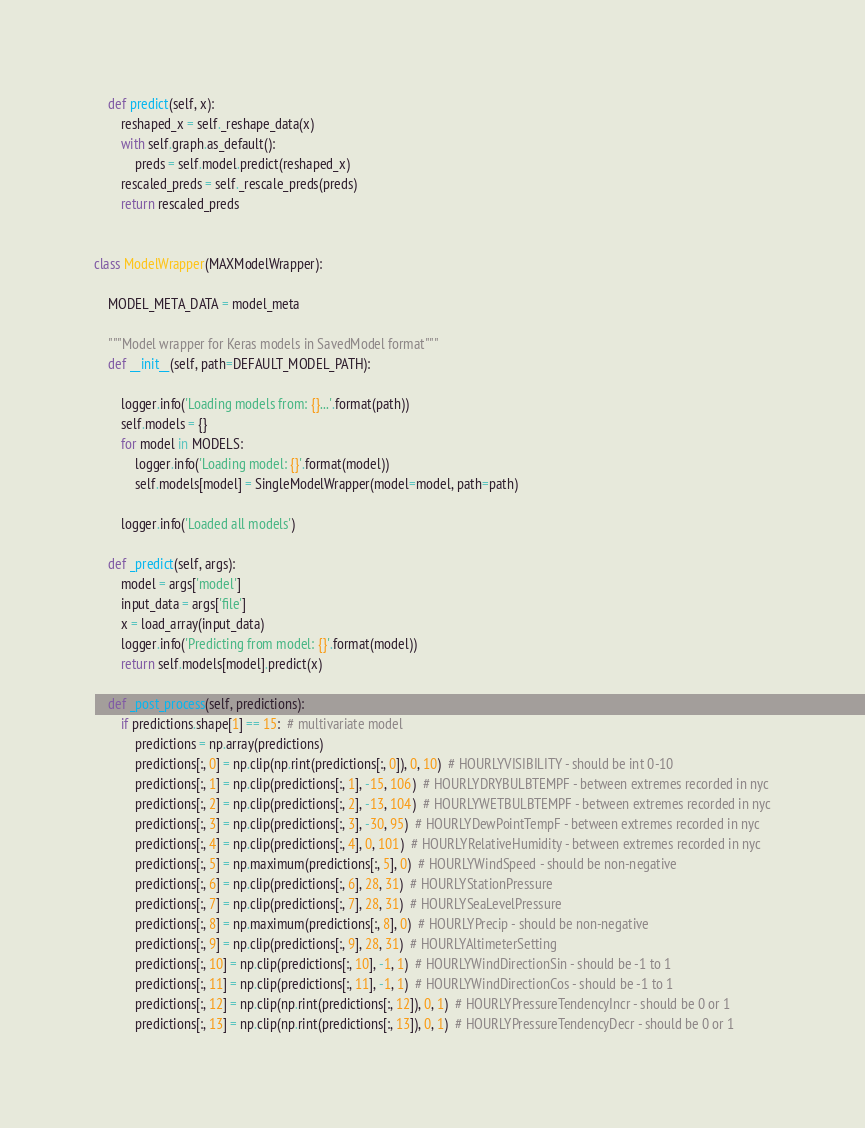Convert code to text. <code><loc_0><loc_0><loc_500><loc_500><_Python_>
    def predict(self, x):
        reshaped_x = self._reshape_data(x)
        with self.graph.as_default():
            preds = self.model.predict(reshaped_x)
        rescaled_preds = self._rescale_preds(preds)
        return rescaled_preds


class ModelWrapper(MAXModelWrapper):

    MODEL_META_DATA = model_meta

    """Model wrapper for Keras models in SavedModel format"""
    def __init__(self, path=DEFAULT_MODEL_PATH):

        logger.info('Loading models from: {}...'.format(path))
        self.models = {}
        for model in MODELS:
            logger.info('Loading model: {}'.format(model))
            self.models[model] = SingleModelWrapper(model=model, path=path)

        logger.info('Loaded all models')

    def _predict(self, args):
        model = args['model']
        input_data = args['file']
        x = load_array(input_data)
        logger.info('Predicting from model: {}'.format(model))
        return self.models[model].predict(x)

    def _post_process(self, predictions):
        if predictions.shape[1] == 15:  # multivariate model
            predictions = np.array(predictions)
            predictions[:, 0] = np.clip(np.rint(predictions[:, 0]), 0, 10)  # HOURLYVISIBILITY - should be int 0-10
            predictions[:, 1] = np.clip(predictions[:, 1], -15, 106)  # HOURLYDRYBULBTEMPF - between extremes recorded in nyc
            predictions[:, 2] = np.clip(predictions[:, 2], -13, 104)  # HOURLYWETBULBTEMPF - between extremes recorded in nyc
            predictions[:, 3] = np.clip(predictions[:, 3], -30, 95)  # HOURLYDewPointTempF - between extremes recorded in nyc
            predictions[:, 4] = np.clip(predictions[:, 4], 0, 101)  # HOURLYRelativeHumidity - between extremes recorded in nyc
            predictions[:, 5] = np.maximum(predictions[:, 5], 0)  # HOURLYWindSpeed - should be non-negative
            predictions[:, 6] = np.clip(predictions[:, 6], 28, 31)  # HOURLYStationPressure
            predictions[:, 7] = np.clip(predictions[:, 7], 28, 31)  # HOURLYSeaLevelPressure
            predictions[:, 8] = np.maximum(predictions[:, 8], 0)  # HOURLYPrecip - should be non-negative
            predictions[:, 9] = np.clip(predictions[:, 9], 28, 31)  # HOURLYAltimeterSetting
            predictions[:, 10] = np.clip(predictions[:, 10], -1, 1)  # HOURLYWindDirectionSin - should be -1 to 1
            predictions[:, 11] = np.clip(predictions[:, 11], -1, 1)  # HOURLYWindDirectionCos - should be -1 to 1
            predictions[:, 12] = np.clip(np.rint(predictions[:, 12]), 0, 1)  # HOURLYPressureTendencyIncr - should be 0 or 1
            predictions[:, 13] = np.clip(np.rint(predictions[:, 13]), 0, 1)  # HOURLYPressureTendencyDecr - should be 0 or 1</code> 